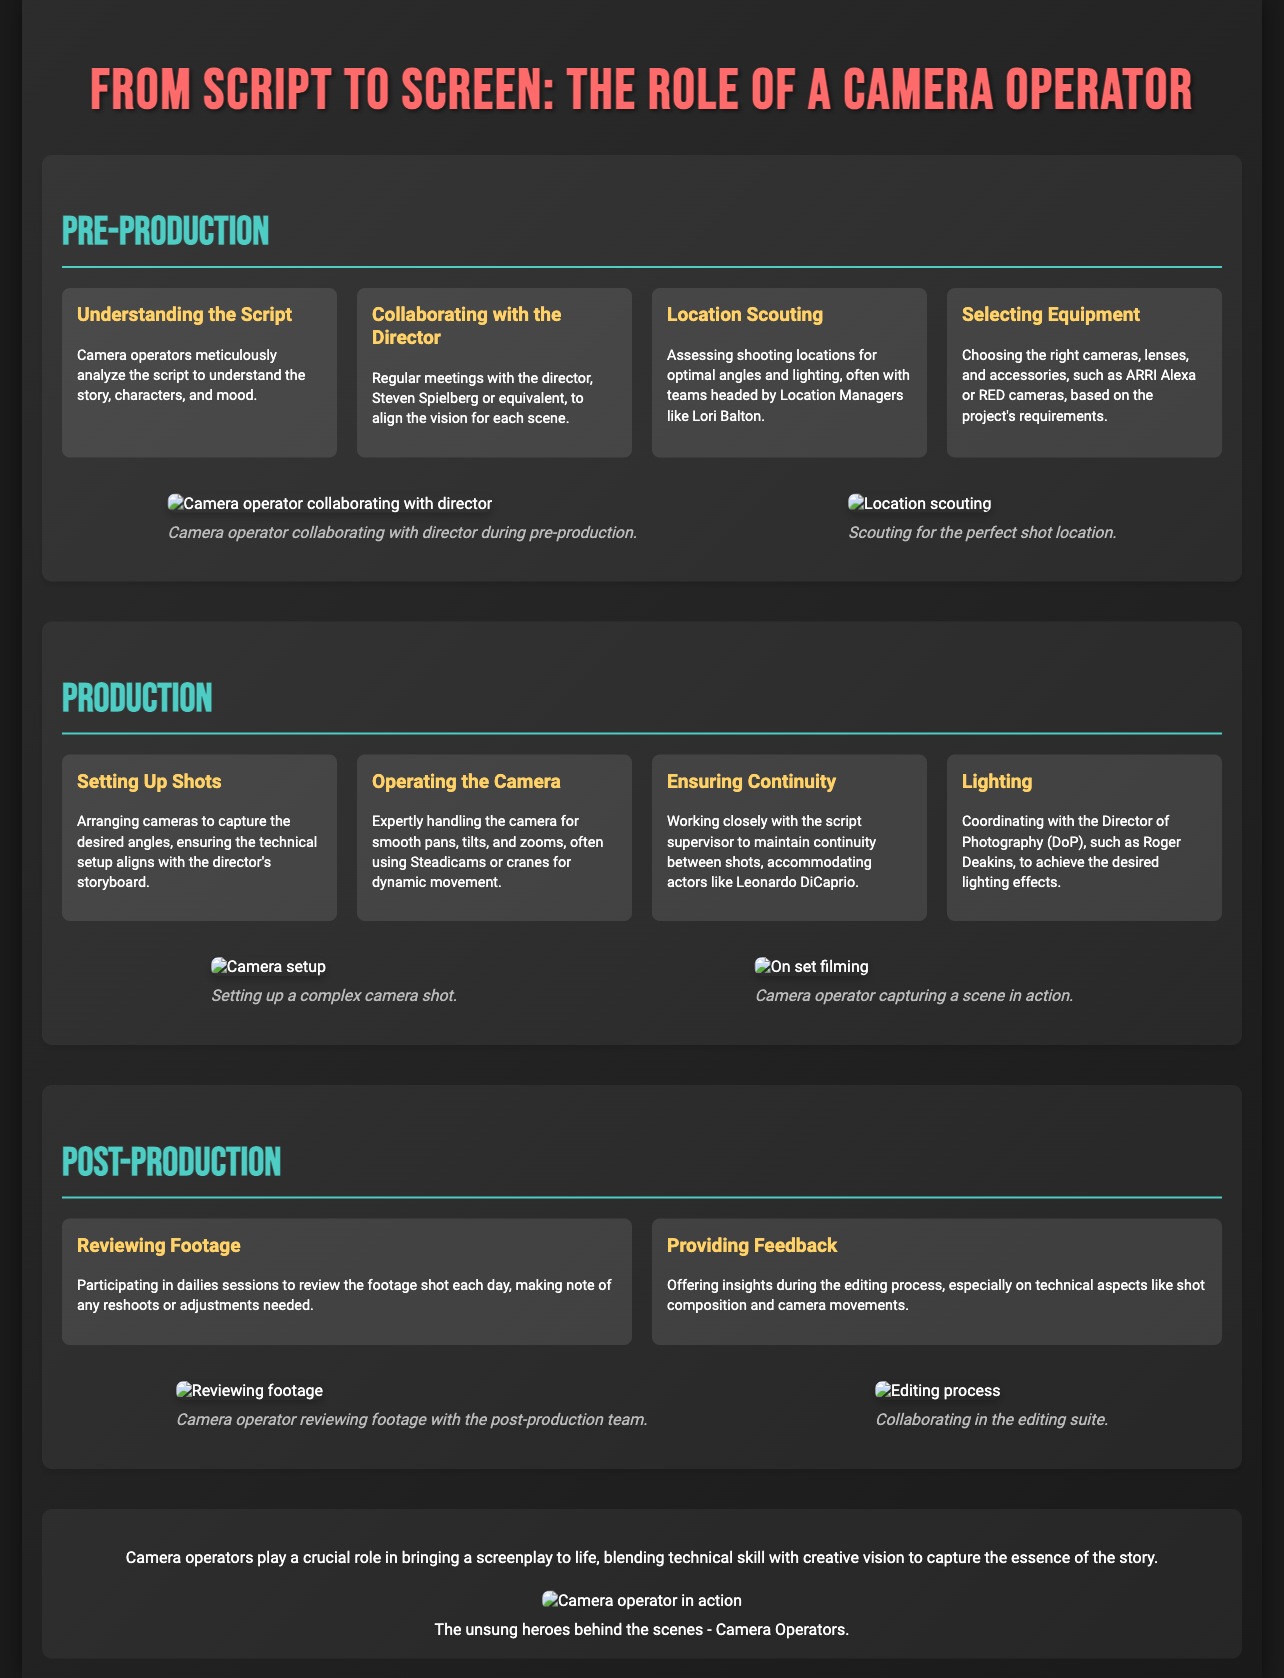What is the title of the poster? The title of the poster is clearly stated at the top, which is "From Script to Screen: The Role of a Camera Operator."
Answer: From Script to Screen: The Role of a Camera Operator Who is mentioned as a Location Manager? The document lists Lori Balton as a Location Manager associated with location scouting.
Answer: Lori Balton What is one type of equipment mentioned in the poster? The poster specifies camera equipment choices, particularly naming ARRI Alexa and RED cameras as examples.
Answer: ARRI Alexa What stage comes after production? The segments of the poster are organized chronologically with pre-production, production, and then post-production.
Answer: Post-Production What is the role of a Camera Operator? The poster emphasizes the diverse responsibilities of a Camera Operator, such as capturing the story, managing camera setups, and ensuring continuity.
Answer: Capturing the story How do Camera Operators work with directors? The document describes regular meetings and collaboration between camera operators and directors to align on the scene's vision.
Answer: Collaborating What visual element accompanies the “Reviewing Footage” section? Each section includes relevant graphics, and the “Reviewing Footage” section features an image of a camera operator with the post-production team.
Answer: Camera operator reviewing footage What color is used for the section titles? The color scheme for the section titles highlights them with a specific hue consistent throughout the poster.
Answer: #4ecdc4 How does the poster format the information? The structure of the document utilizes headers, sections, and a clear visual grid layout for organized information presentation.
Answer: Grid layout 